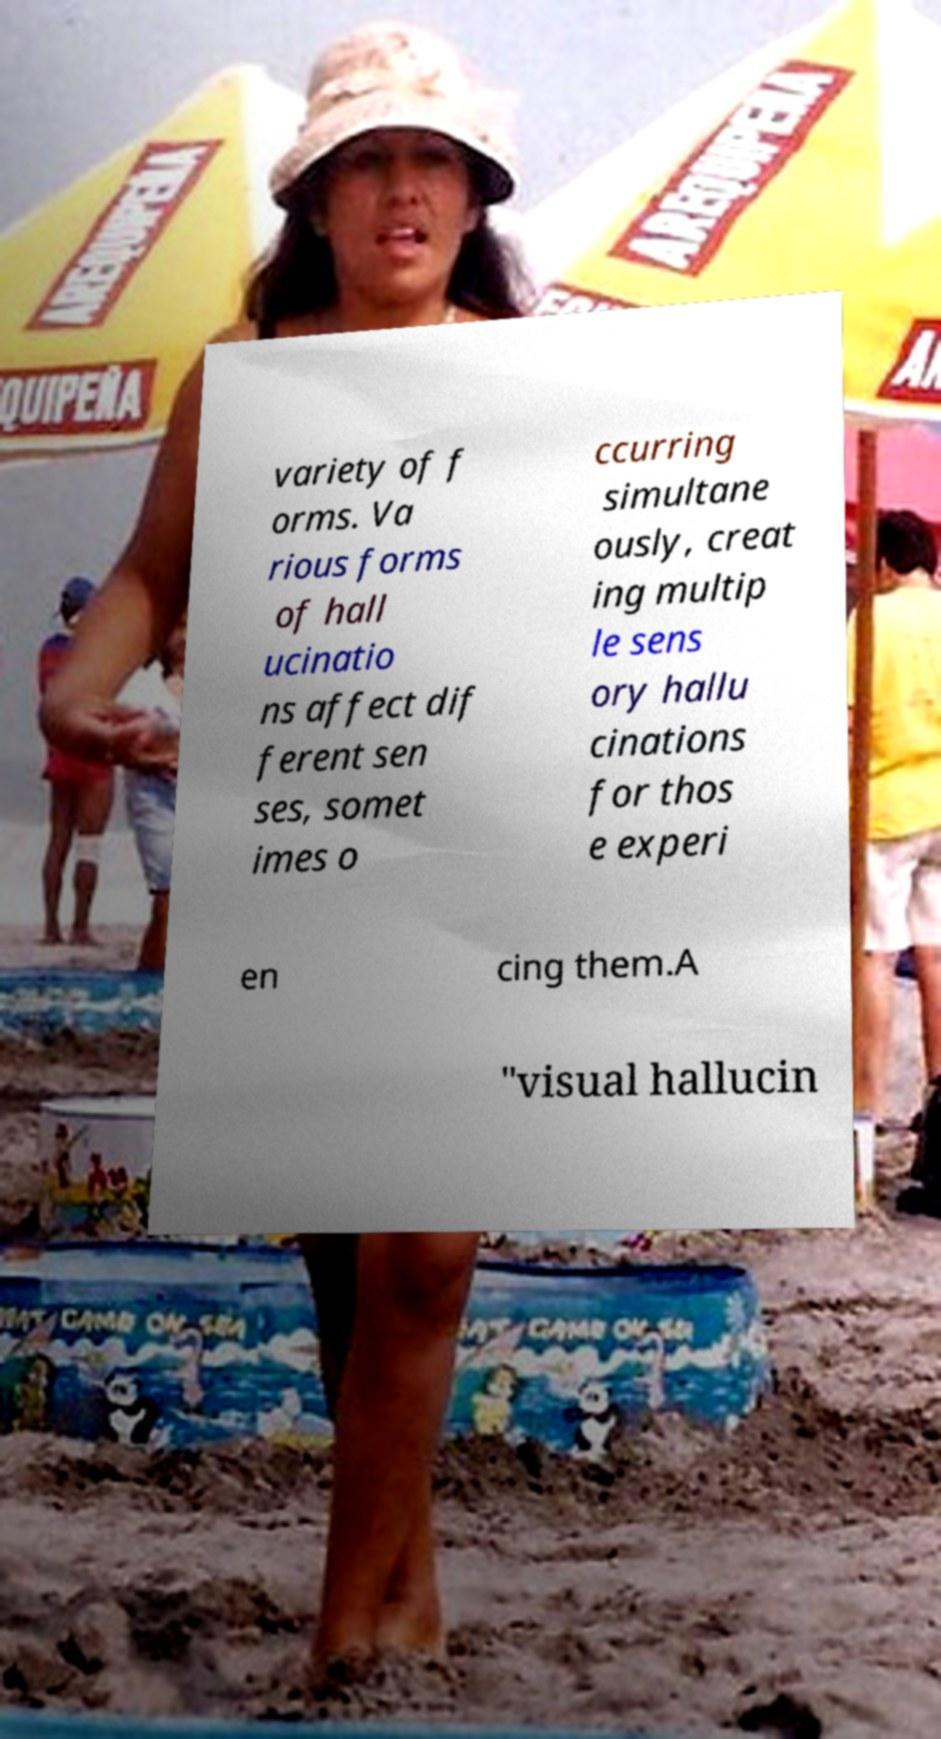I need the written content from this picture converted into text. Can you do that? variety of f orms. Va rious forms of hall ucinatio ns affect dif ferent sen ses, somet imes o ccurring simultane ously, creat ing multip le sens ory hallu cinations for thos e experi en cing them.A "visual hallucin 